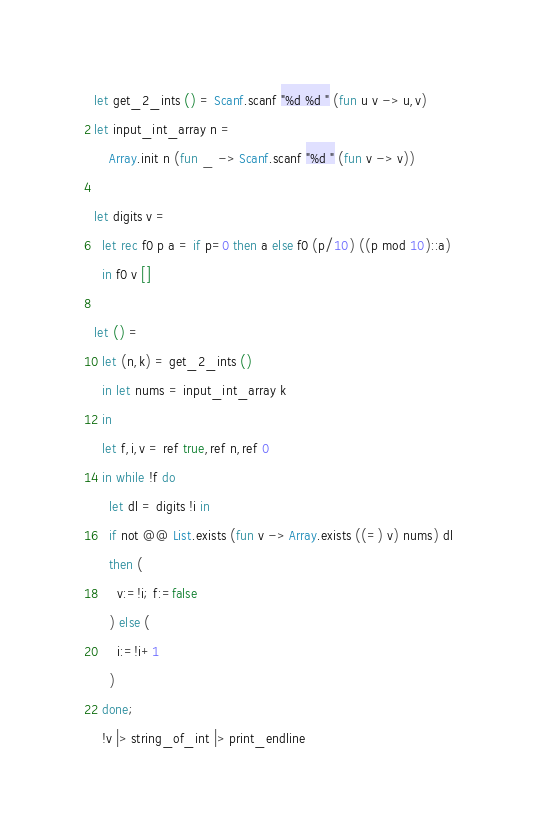<code> <loc_0><loc_0><loc_500><loc_500><_OCaml_>let get_2_ints () = Scanf.scanf "%d %d " (fun u v -> u,v)
let input_int_array n =
	Array.init n (fun _ -> Scanf.scanf "%d " (fun v -> v))

let digits v =
  let rec f0 p a = if p=0 then a else f0 (p/10) ((p mod 10)::a)
  in f0 v []

let () = 
  let (n,k) = get_2_ints ()
  in let nums = input_int_array k
  in
  let f,i,v = ref true,ref n,ref 0
  in while !f do
    let dl = digits !i in
    if not @@ List.exists (fun v -> Array.exists ((=) v) nums) dl
    then (
      v:=!i; f:=false
    ) else (
      i:=!i+1
    )
  done;
  !v |> string_of_int |> print_endline</code> 